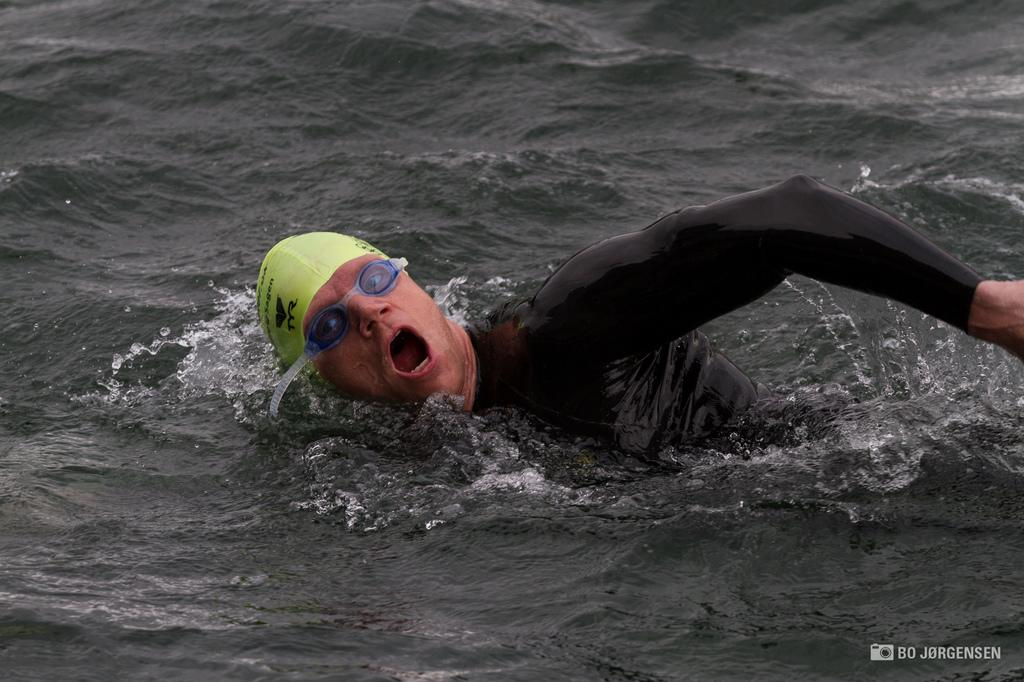Who is present in the image? There is a man in the image. What is the man doing in the image? The man is swimming in the water. What accessories is the man wearing while swimming? The man is wearing a cap and goggles. What type of chalk is the man using to draw in the water? There is no chalk present in the image, and the man is swimming, not drawing. 